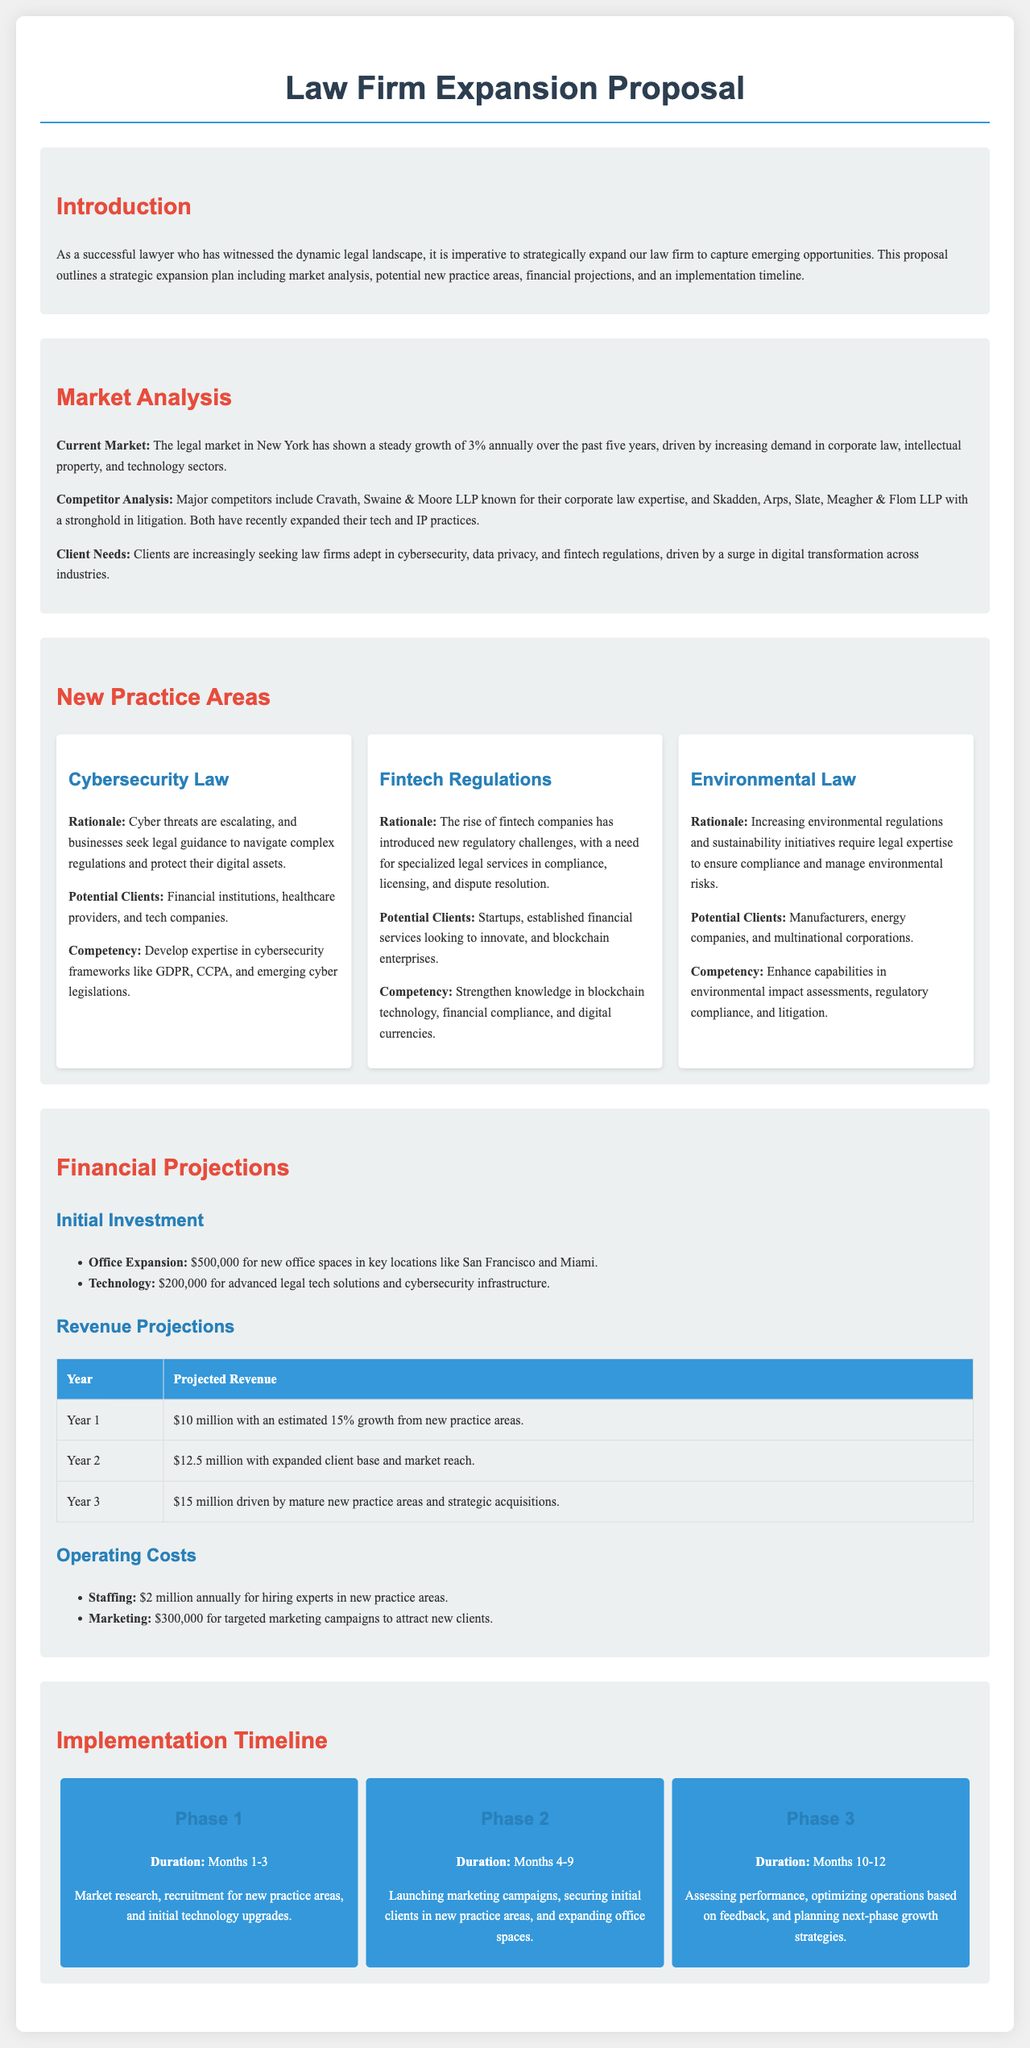what is the growth rate of the legal market in New York? The current market shows a steady growth of 3% annually over the past five years.
Answer: 3% who are the major competitors mentioned in the proposal? The proposal mentions Cravath, Swaine & Moore LLP and Skadden, Arps, Slate, Meagher & Flom LLP as major competitors.
Answer: Cravath, Swaine & Moore LLP and Skadden, Arps, Slate, Meagher & Flom LLP what is the initial investment for office expansion? The initial investment for office expansion is explicitly stated in the document as $500,000.
Answer: $500,000 how much is projected revenue in Year 2? Year 2's projected revenue is detailed in the document, which indicates it will be $12.5 million.
Answer: $12.5 million what new practice area is concerned with cybersecurity? The new practice area dedicated to cybersecurity is titled Cybersecurity Law.
Answer: Cybersecurity Law what phase includes launching marketing campaigns? The document specifies that launching marketing campaigns occurs in Phase 2, which is from Months 4 to 9.
Answer: Phase 2 how much is allocated for advanced legal tech solutions? The document details that $200,000 is allocated for advanced legal tech solutions.
Answer: $200,000 who is the target client for the new practice area focused on Environmental Law? Potential clients for Environmental Law include manufacturers, energy companies, and multinational corporations.
Answer: Manufacturers, energy companies, and multinational corporations what is the duration of Phase 1 in the implementation timeline? The duration of Phase 1 is clearly outlined in the document as Months 1-3.
Answer: Months 1-3 